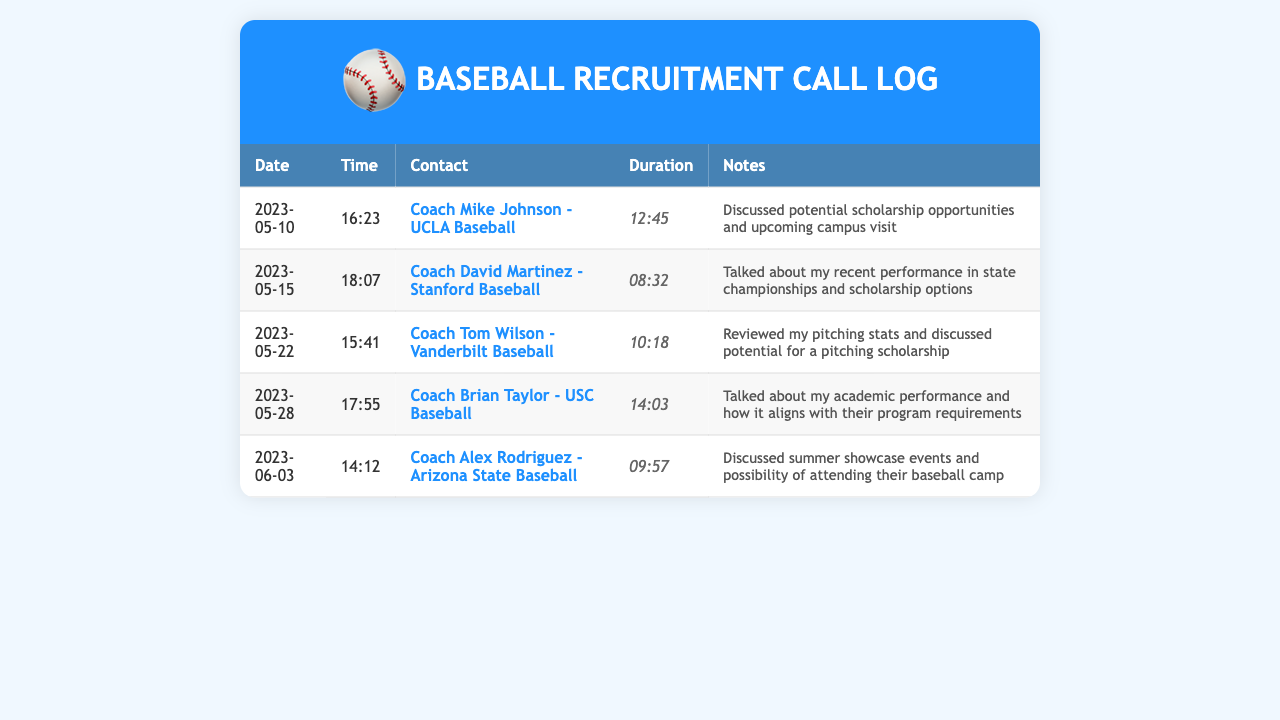what is the date of the call with Coach Mike Johnson? The date is directly taken from the first record in the table where Coach Mike Johnson is mentioned.
Answer: 2023-05-10 how long was the conversation with Coach David Martinez? The duration is listed in the row corresponding to Coach David Martinez's conversation.
Answer: 08:32 which college baseball program did Coach Tom Wilson represent? The information is found in the contact name for the call with Tom Wilson.
Answer: Vanderbilt Baseball what was discussed during the call with Coach Brian Taylor? The notes in the record detail the topics of conversation with Coach Brian Taylor.
Answer: Academic performance how many recruiters were contacted before June 2023? By counting the calls listed prior to June in the document, we can determine the total.
Answer: 5 which coach discussed pitching scholarship potential? Referring to the notes for each conversation, the coach who focused on pitching scholarships can be identified.
Answer: Coach Tom Wilson what time did the call with Coach Alex Rodriguez start? The time is specified in the record for the call with Coach Alex Rodriguez.
Answer: 14:12 how many minutes long was the longest conversation? The durations of all conversations are listed, and the longest can be identified through comparison.
Answer: 14:03 what is the main focus of the calls listed in the document? The common theme across the calls can be inferred from the notes provided.
Answer: Scholarship opportunities 